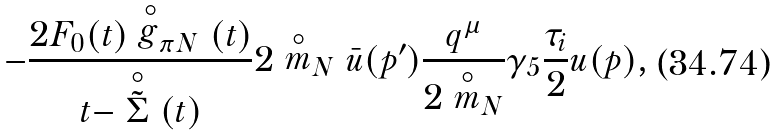<formula> <loc_0><loc_0><loc_500><loc_500>- \frac { 2 F _ { 0 } ( t ) \stackrel { \circ } { g } _ { \pi N } ( t ) } { t - \stackrel { \circ } { \tilde { \Sigma } } ( t ) } 2 \stackrel { \circ } { m } _ { N } \bar { u } ( p ^ { \prime } ) \frac { q ^ { \mu } } { 2 \stackrel { \circ } { m } _ { N } } \gamma _ { 5 } \frac { \tau _ { i } } { 2 } u ( p ) ,</formula> 